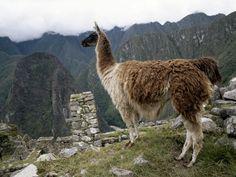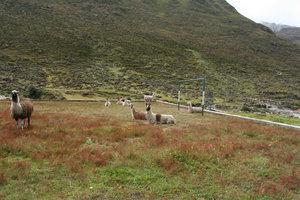The first image is the image on the left, the second image is the image on the right. For the images displayed, is the sentence "The left image includes a leftward-facing brown-and-white llama standing at the edge of a cliff, with mountains in the background." factually correct? Answer yes or no. Yes. 